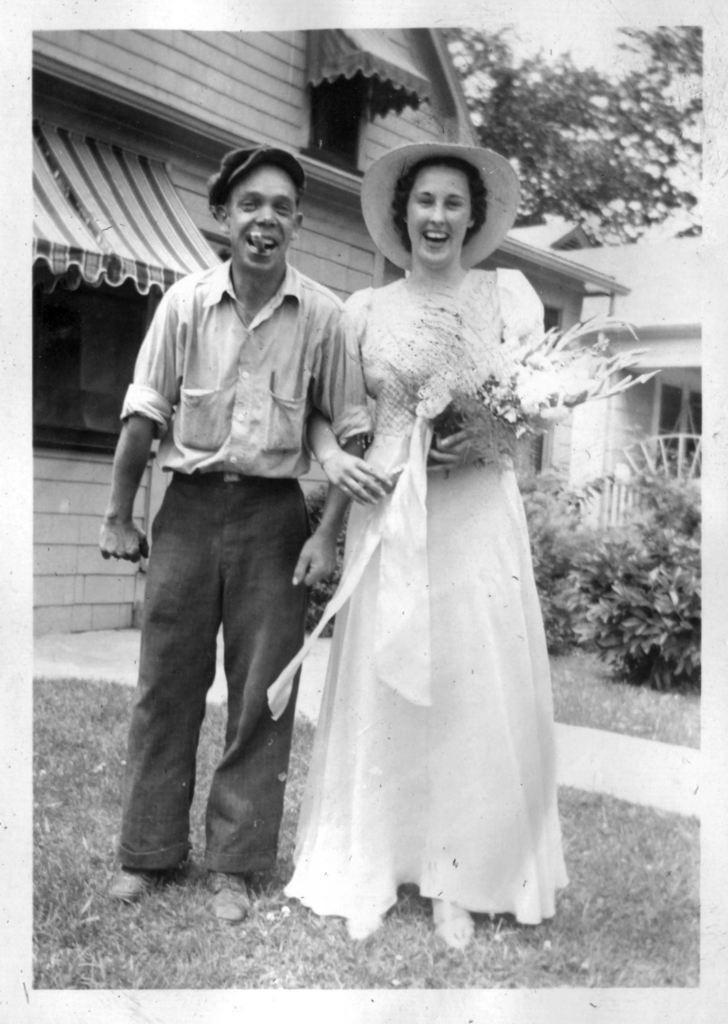Describe this image in one or two sentences. This is a black and white image , where there are two persons standing, a person holding a bouquet , and there is a shop and a house , and there are plants and trees. 